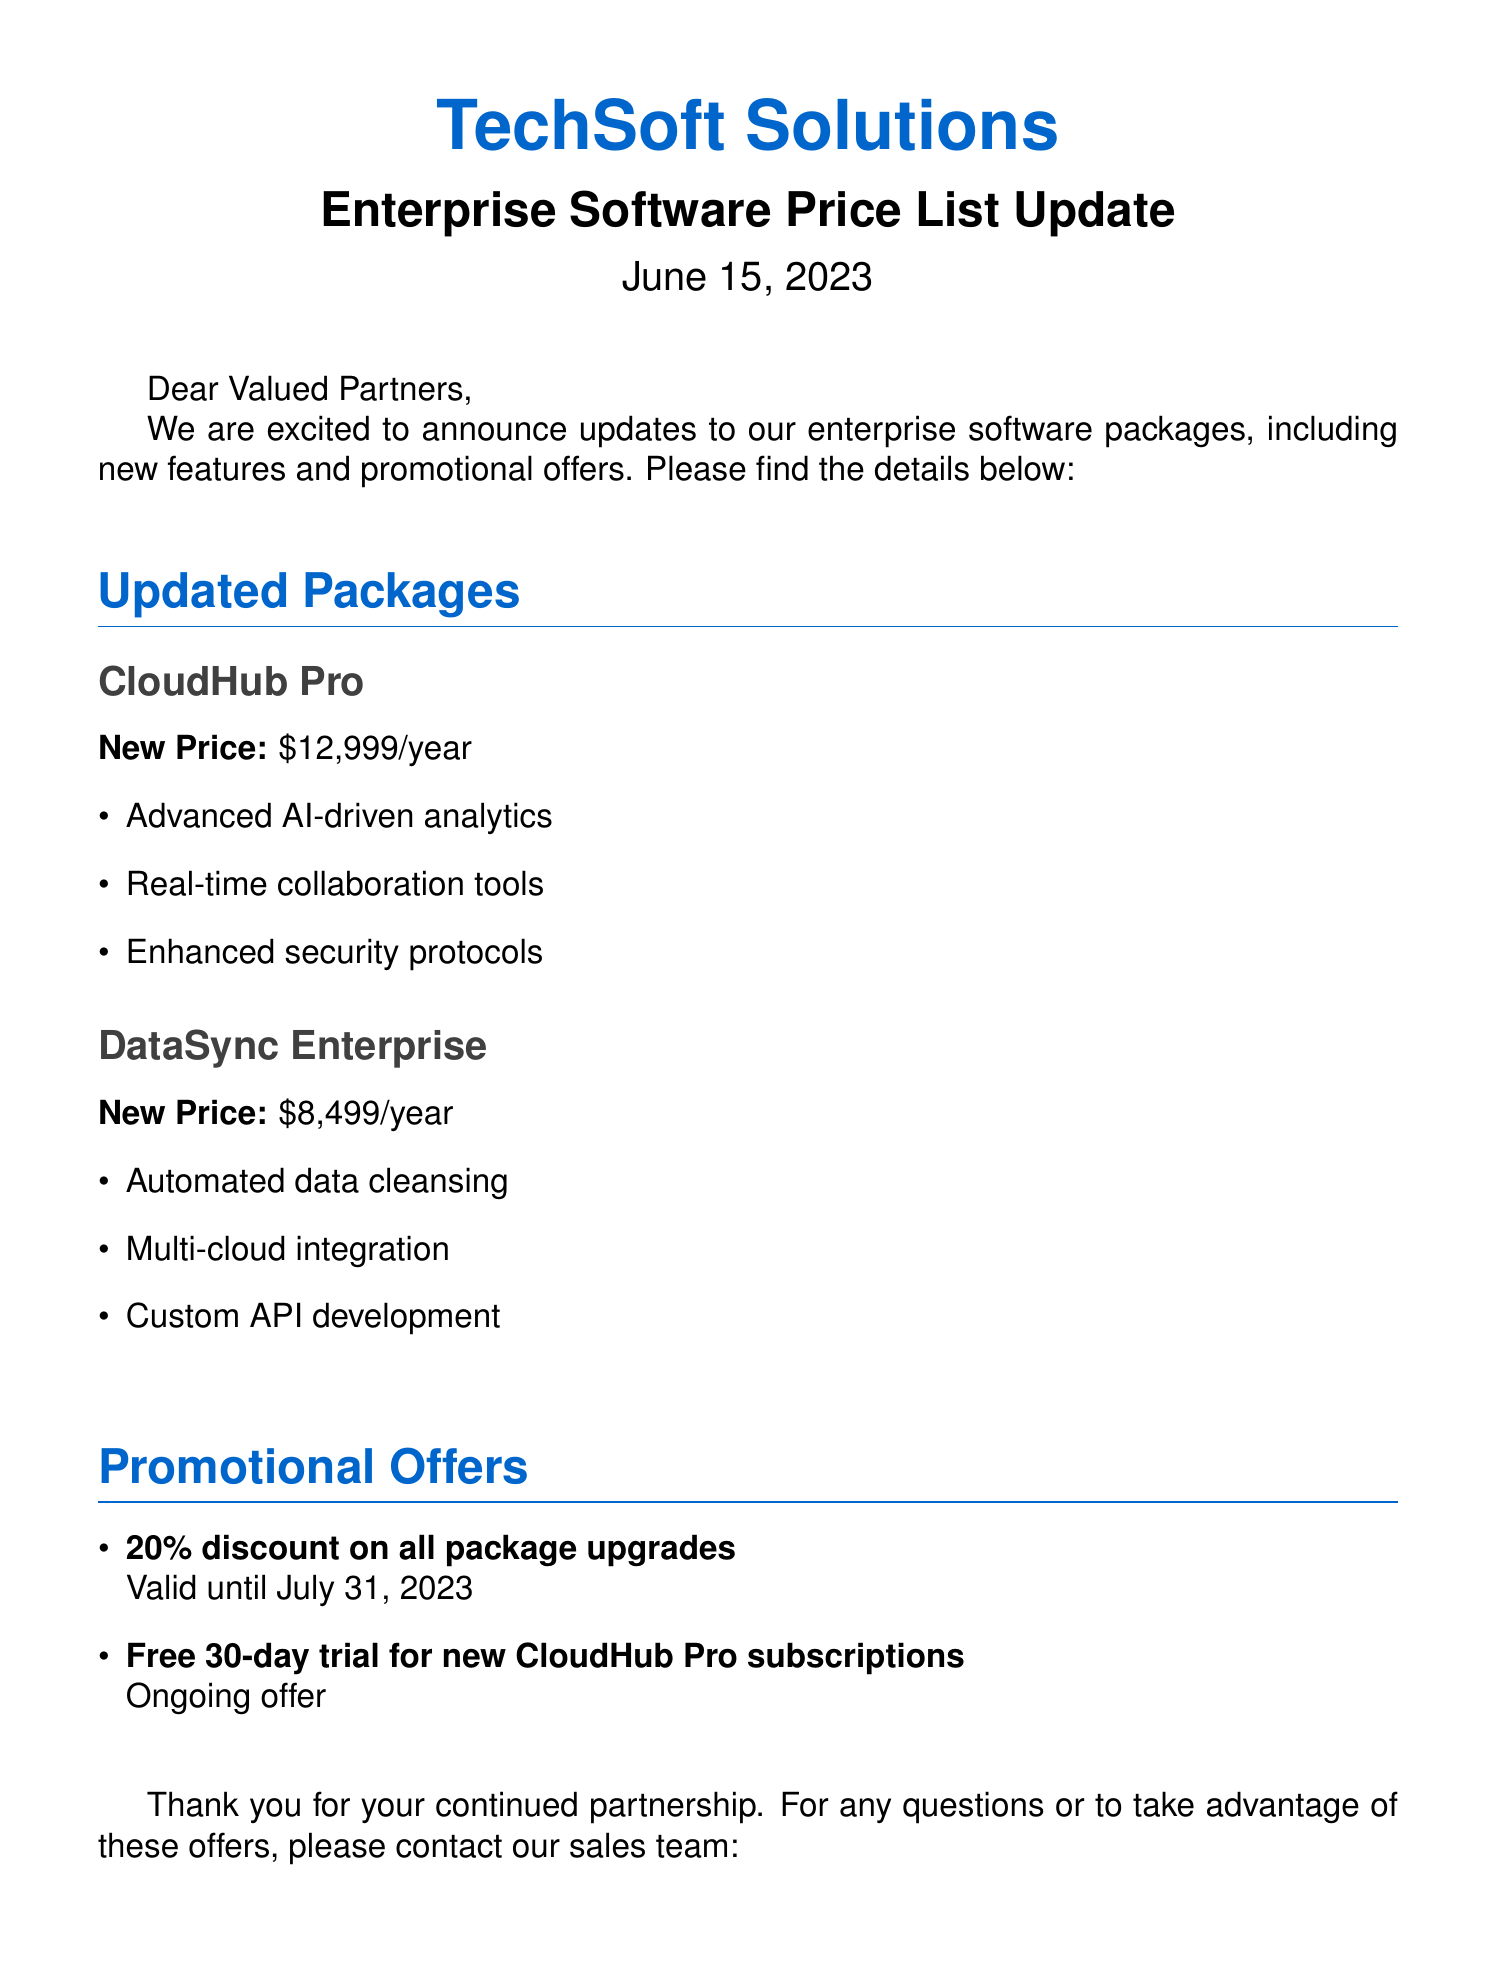What is the new price for CloudHub Pro? The new price for CloudHub Pro is specified directly in the document.
Answer: $12,999/year What new feature has been added in DataSync Enterprise? The document lists new features in DataSync Enterprise, such as automated data cleansing.
Answer: Automated data cleansing When does the 20% discount on all package upgrades expire? The expiration date for the discount is clearly mentioned in the promotional offers section.
Answer: July 31, 2023 What promotional offer is available for new CloudHub Pro subscriptions? The document details a specific promotional offer related to CloudHub Pro subscriptions.
Answer: Free 30-day trial What is the contact email for the sales team? The document provides contact details, including the email address for inquiries.
Answer: enterprise.sales@techsoftsolutions.com Which software package has multi-cloud integration as a feature? The document specifies features for each package, identifying which one includes multi-cloud integration.
Answer: DataSync Enterprise What type of document is this? The closing statement of the document indicates its classification.
Answer: Fax What company is associated with this price list update? The document header identifies the company issuing the price list update.
Answer: TechSoft Solutions 